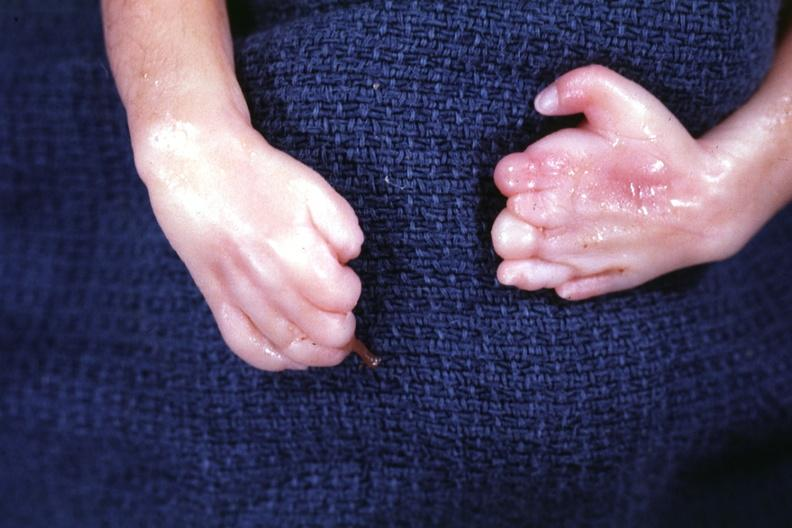what is both hands deformed?
Answer the question using a single word or phrase. Fingers 